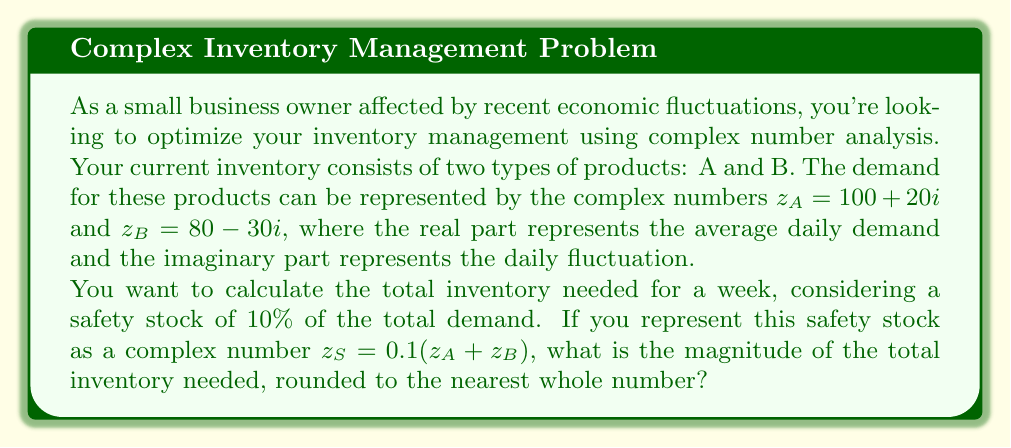Could you help me with this problem? Let's approach this step-by-step:

1) First, we need to calculate the total demand for a week:
   $$z_T = 7(z_A + z_B)$$

2) Let's add $z_A$ and $z_B$:
   $$z_A + z_B = (100 + 20i) + (80 - 30i) = 180 - 10i$$

3) Now, multiply by 7 for the weekly demand:
   $$z_T = 7(180 - 10i) = 1260 - 70i$$

4) Calculate the safety stock:
   $$z_S = 0.1(z_A + z_B) = 0.1(180 - 10i) = 18 - i$$

5) Total inventory needed:
   $$z_I = z_T + z_S = (1260 - 70i) + (18 - i) = 1278 - 71i$$

6) To find the magnitude of $z_I$, we use the formula $|z| = \sqrt{a^2 + b^2}$ where $z = a + bi$:
   $$|z_I| = \sqrt{1278^2 + (-71)^2} = \sqrt{1633684 + 5041} = \sqrt{1638725}$$

7) Calculate the square root:
   $$|z_I| \approx 1280.13$$

8) Rounding to the nearest whole number:
   $$|z_I| \approx 1280$$
Answer: 1280 